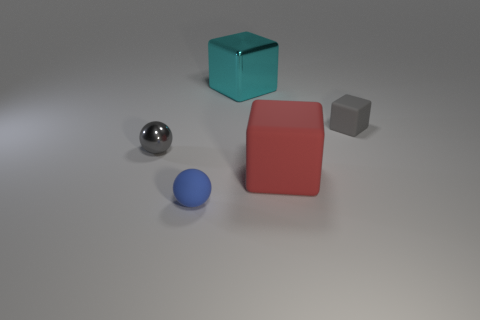There is a red block that is made of the same material as the tiny blue ball; what size is it?
Provide a short and direct response. Large. Does the cyan thing have the same size as the ball that is in front of the red object?
Make the answer very short. No. There is a big cube in front of the tiny metal object; what material is it?
Keep it short and to the point. Rubber. There is a metallic object that is left of the cyan object; what number of cyan metal objects are on the left side of it?
Keep it short and to the point. 0. Is there a large matte object that has the same shape as the small blue rubber thing?
Keep it short and to the point. No. Is the size of the gray thing to the left of the small gray rubber object the same as the rubber thing behind the red thing?
Your answer should be compact. Yes. The rubber thing that is behind the big red matte object that is behind the blue rubber object is what shape?
Offer a very short reply. Cube. How many red cubes are the same size as the gray block?
Your answer should be very brief. 0. Is there a shiny sphere?
Give a very brief answer. Yes. Is there anything else that has the same color as the big metallic thing?
Provide a succinct answer. No. 